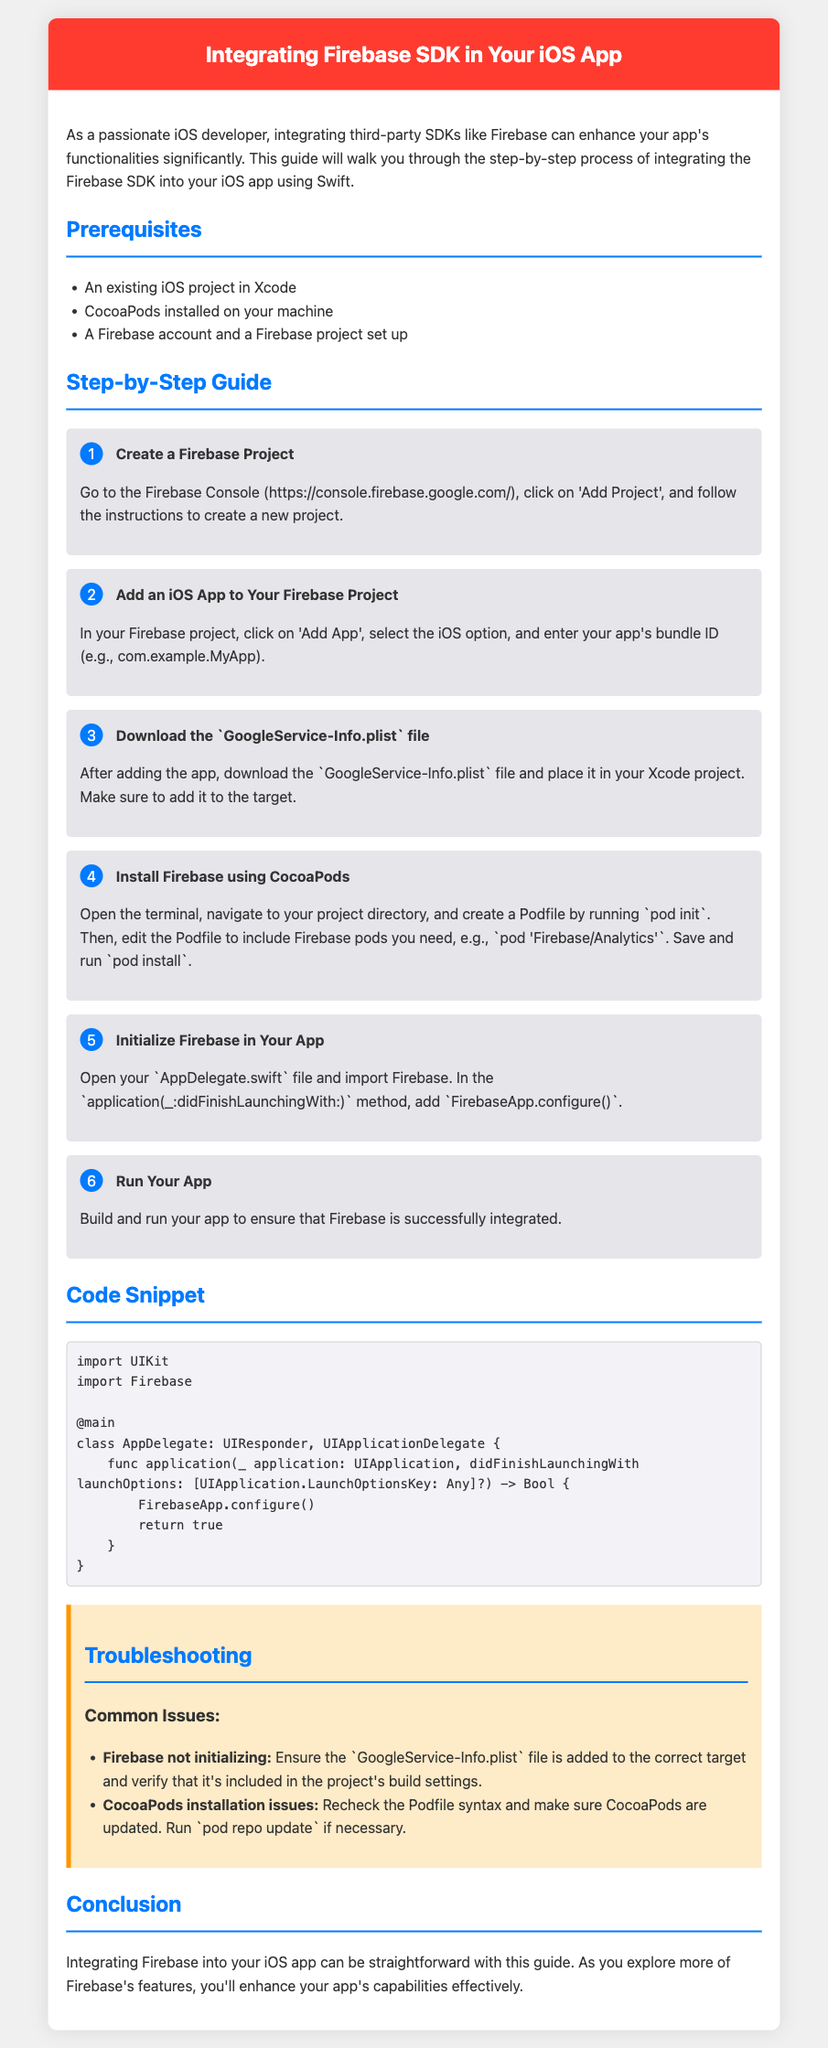What is the first step in integrating Firebase? The first step involves creating a Firebase project in the Firebase Console.
Answer: Create a Firebase Project What file do you need to download after adding the iOS app to Firebase? You need to download the `GoogleService-Info.plist` file.
Answer: GoogleService-Info.plist What command is used to install Firebase using CocoaPods? The command used to install Firebase is `pod install`.
Answer: pod install What should you add to the AppDelegate to initialize Firebase? In the AppDelegate, you should add `FirebaseApp.configure()`.
Answer: FirebaseApp.configure() What is a common issue if Firebase does not initialize? A common issue is that the GoogleService-Info.plist file is not added to the correct target.
Answer: GoogleService-Info.plist How many steps are listed in the guide for integrating Firebase? There are a total of six steps listed in the guide.
Answer: Six What is required to run the Firebase installation successfully? You need to build and run your app to ensure Firebase is integrated successfully.
Answer: Build and run What tool is required for managing dependencies like Firebase in your iOS project? CocoaPods is required for managing dependencies.
Answer: CocoaPods What color is used for the header background in the document? The header background color is a shade of red.
Answer: Red 